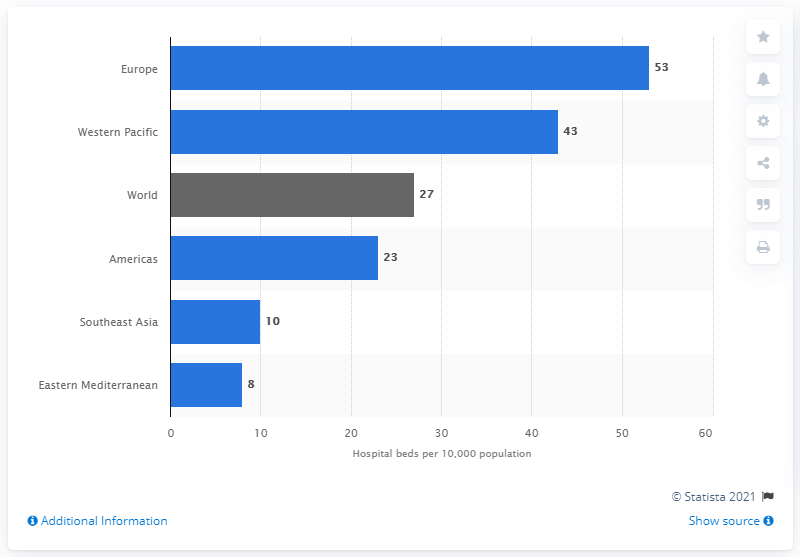Draw attention to some important aspects in this diagram. According to the data, Europe had the highest density of hospital beds per 10,000 of its population. 